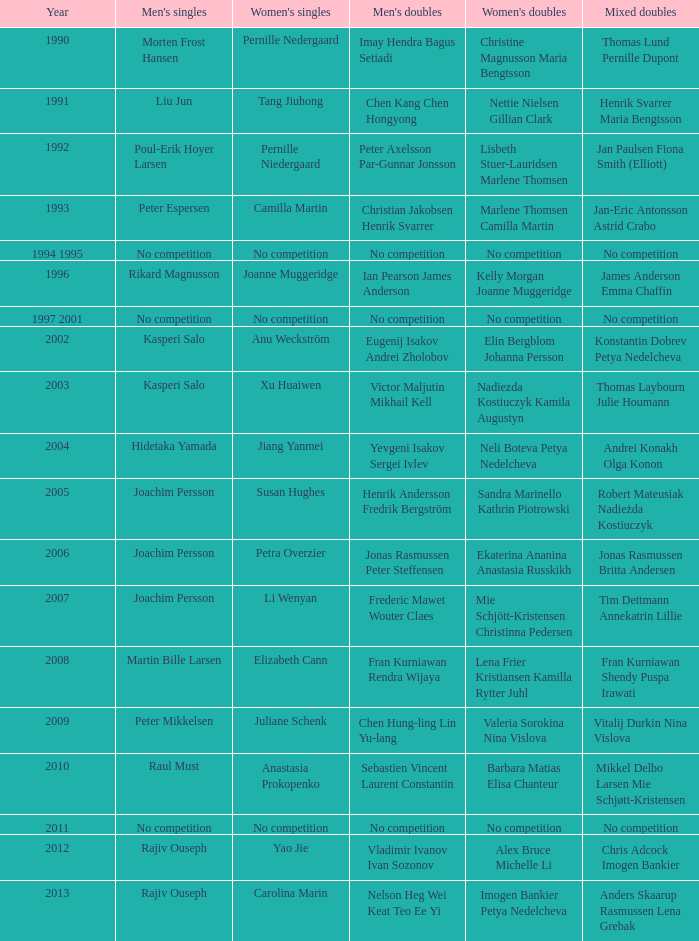What year did Carolina Marin win the Women's singles? 2013.0. 